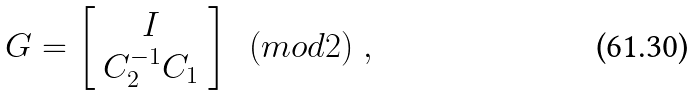<formula> <loc_0><loc_0><loc_500><loc_500>G = \left [ \begin{array} { c } I \\ C _ { 2 } ^ { - 1 } C _ { 1 } \end{array} \right ] \ \ ( m o d 2 ) \ ,</formula> 